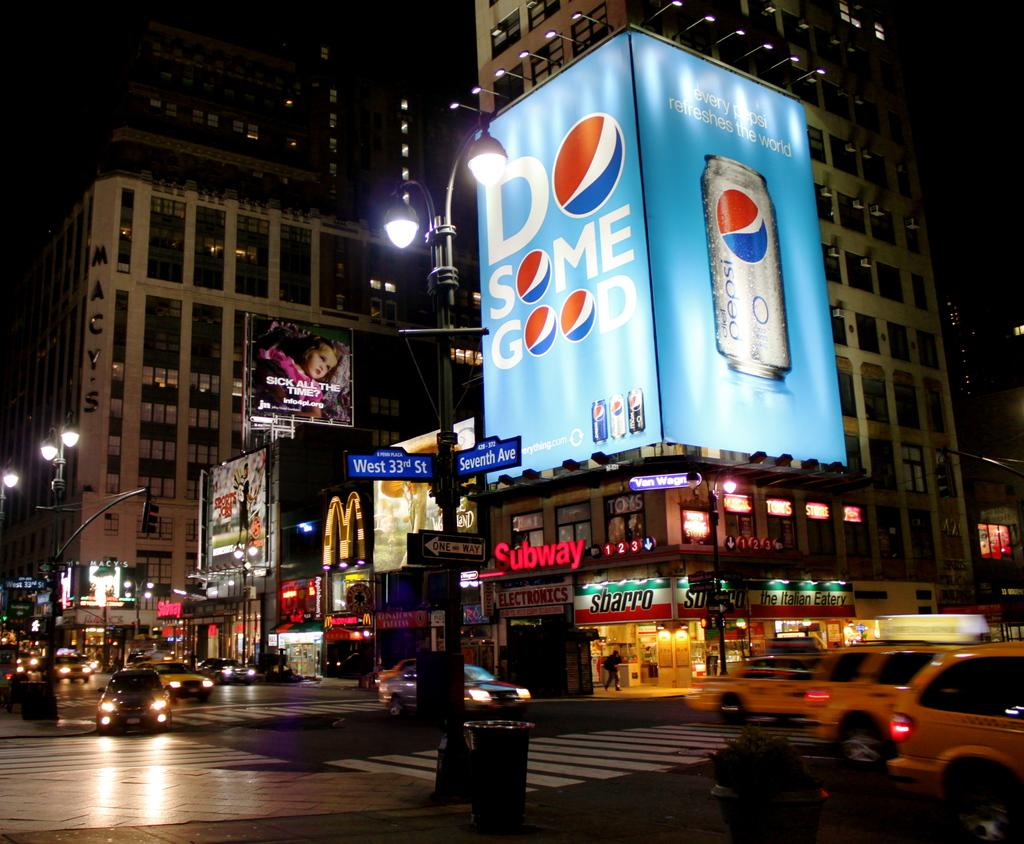<image>
Create a compact narrative representing the image presented. a Pepsi logo that is on a building 